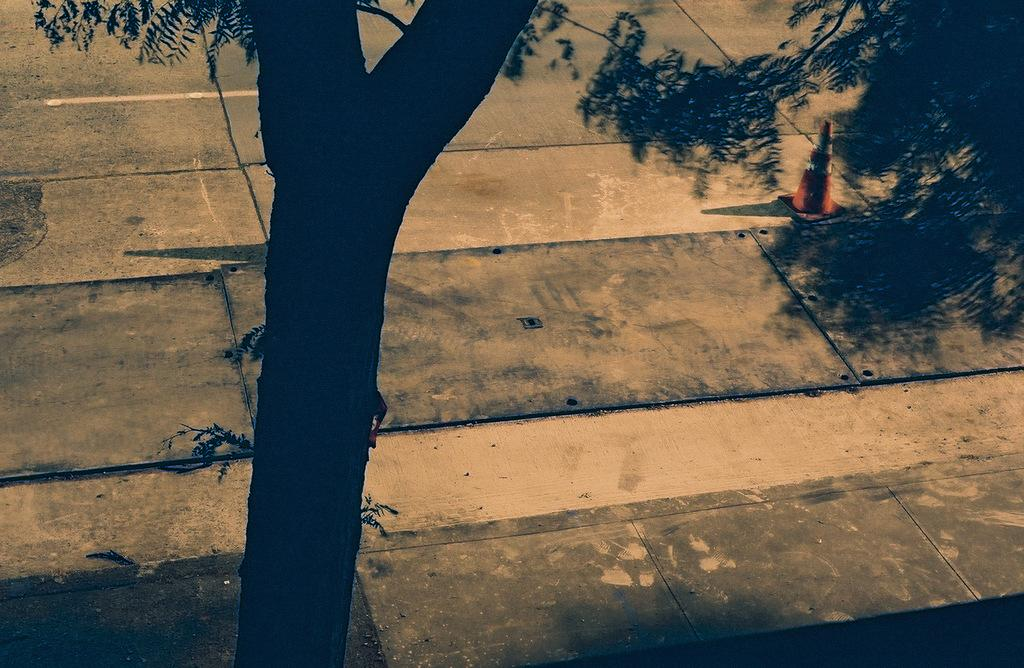What type of plant can be seen in the image? There is a tree in the image. What object is present in the image that is typically used for traffic control? There is a traffic cone in the image. Can you see a crowd of people gathered around the tree in the image? There is no crowd of people present in the image. Is there a river flowing near the tree in the image? There is no river visible in the image. 